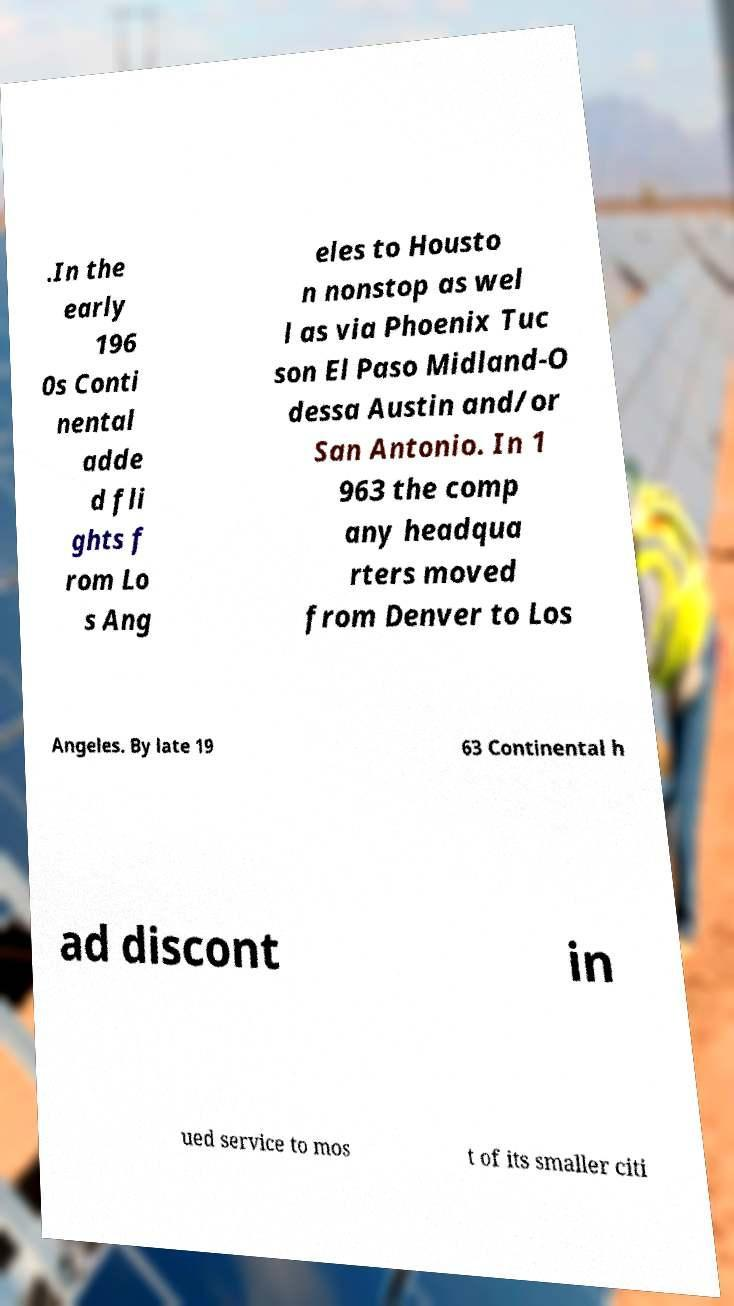Could you assist in decoding the text presented in this image and type it out clearly? .In the early 196 0s Conti nental adde d fli ghts f rom Lo s Ang eles to Housto n nonstop as wel l as via Phoenix Tuc son El Paso Midland-O dessa Austin and/or San Antonio. In 1 963 the comp any headqua rters moved from Denver to Los Angeles. By late 19 63 Continental h ad discont in ued service to mos t of its smaller citi 